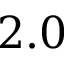<formula> <loc_0><loc_0><loc_500><loc_500>2 . 0</formula> 